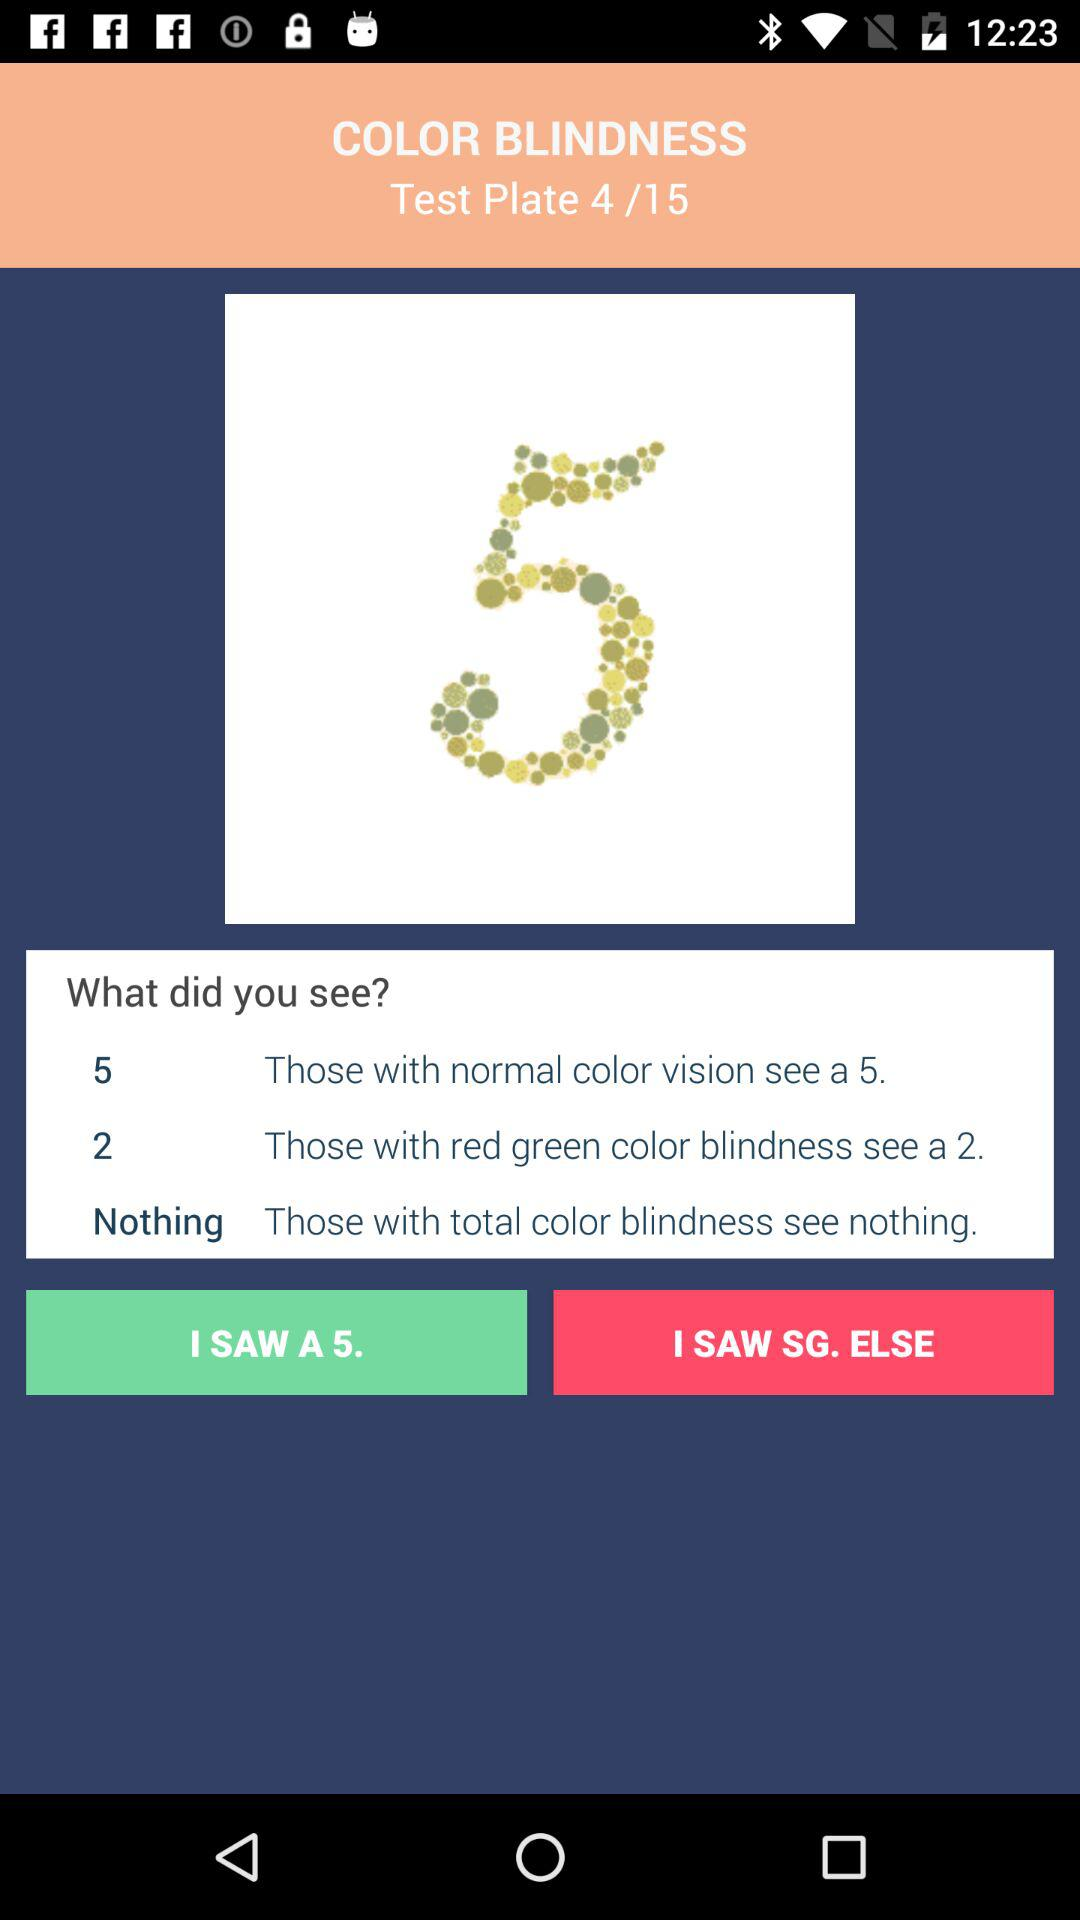Who sees a 2 on the plate? The person with red green color blindness sees a 2 on the plate. 